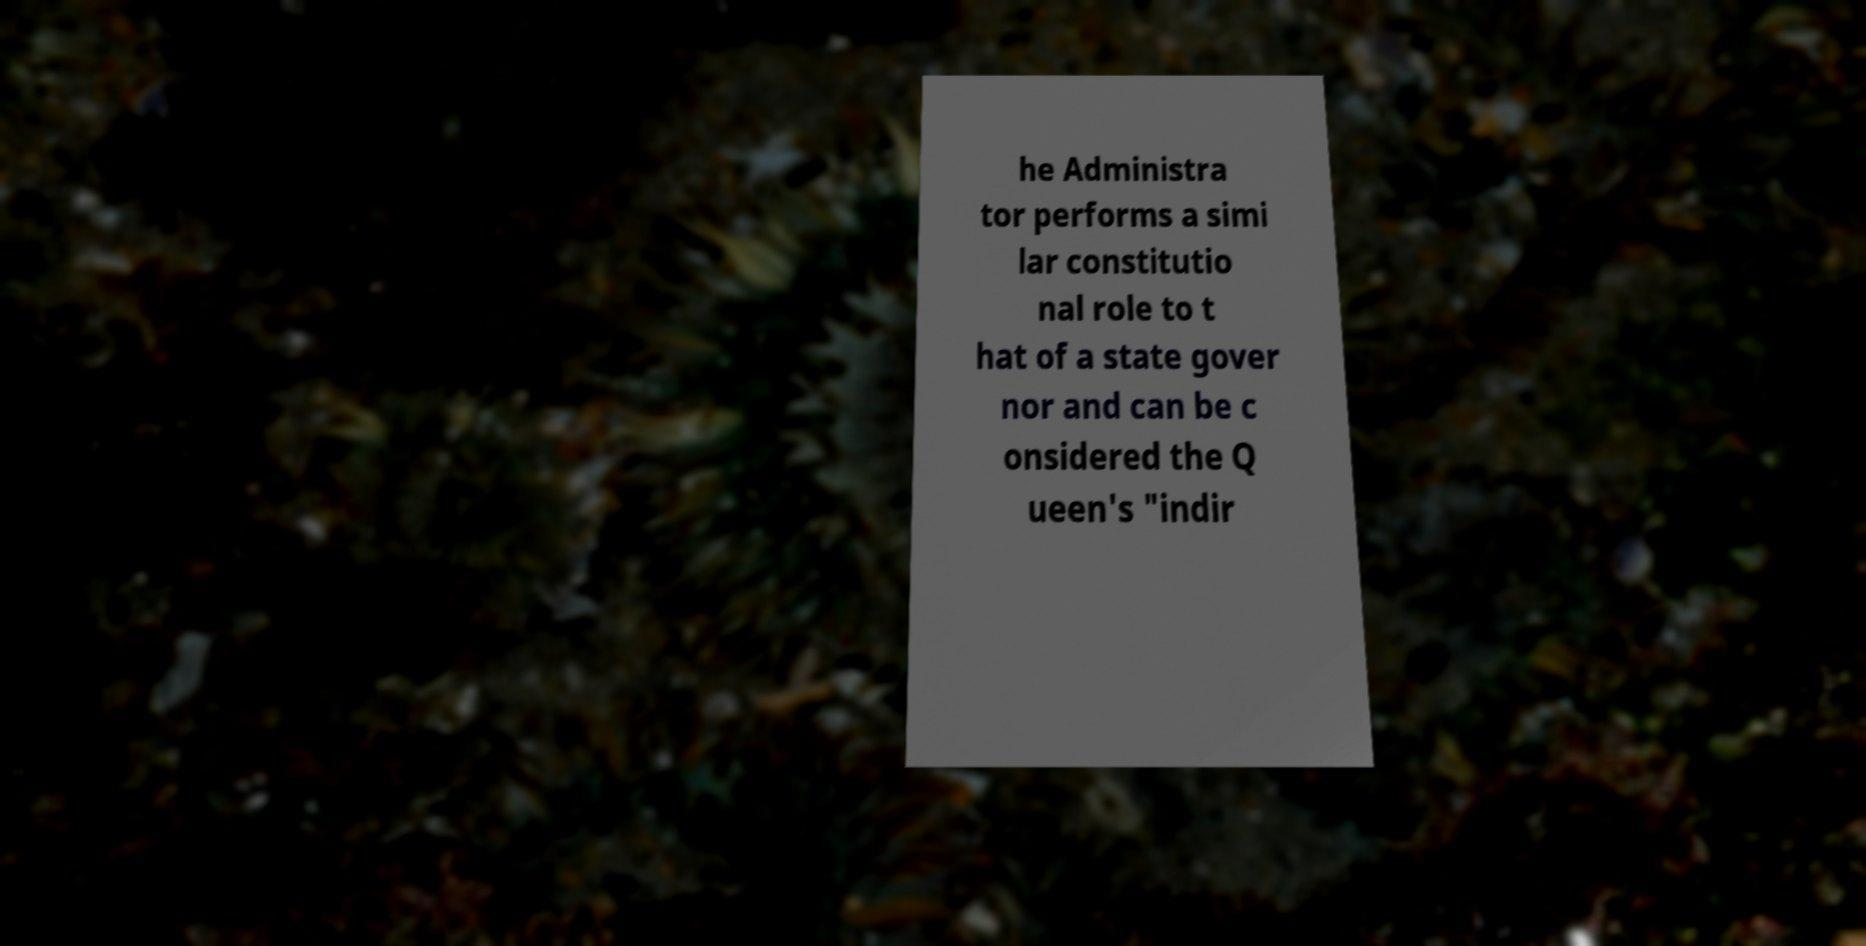Can you read and provide the text displayed in the image?This photo seems to have some interesting text. Can you extract and type it out for me? he Administra tor performs a simi lar constitutio nal role to t hat of a state gover nor and can be c onsidered the Q ueen's "indir 